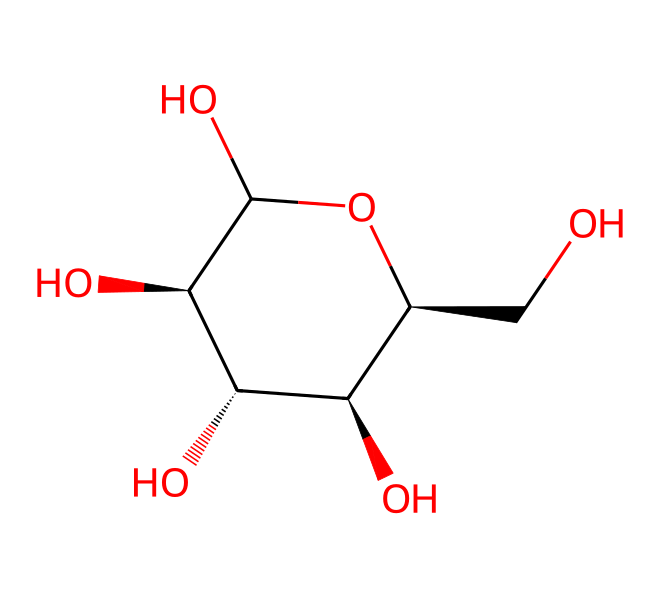What is the molecular formula of this compound? To determine the molecular formula, we need to count the number of each type of atom in the SMILES representation. The structure represents a carbohydrate, specifically cellulose, which contains carbon (C), hydrogen (H), and oxygen (O). By analyzing the SMILES, we identify 6 carbon atoms, 10 hydrogen atoms, and 5 oxygen atoms, resulting in the molecular formula C6H10O5.
Answer: C6H10O5 How many hydroxyl (OH) groups are present in this structure? The presence of hydroxyl groups can be determined by identifying -OH functional groups in the structure. Each carbon in cellulose typically has a hydroxyl group attached, and by inspecting the structure from the SMILES representation, we find 4 distinct hydroxyl groups attached to the carbon backbone.
Answer: 4 What type of bonds are primarily present in this compound? Aliphatic compounds, like cellulose, predominantly contain single (sigma) bonds. By analyzing the SMILES, we can observe that the connections between the carbon atoms and with other functional groups are mainly single bonds. Additional checks for double or triple bonds reveal none present, confirming the presence of single bonds.
Answer: single bonds What is the significance of this compound in biofuels? The significance of cellulose in biofuels lies in its potential as a renewable resource. It is a polysaccharide that can be broken down into glucose through enzymatic hydrolysis, which can then be fermented to produce ethanol. This sustainable process directly connects cellulose to biofuel production, emphasizing its role in reducing dependence on fossil fuels.
Answer: renewable resource Is this compound a simple sugar or a polysaccharide? By examining the structure, we can determine the classification of the carbohydrate. The chemical in question is a complex molecule formed by multiple monosaccharide units, making it a polysaccharide, as opposed to a simple sugar like glucose which consists of a single unit.
Answer: polysaccharide How many rings are present in the structure? The structure depicted in the SMILES represents a cyclic structure which is typical for polysaccharides. In cellulose, we don't see distinct rings as in cyclic compounds but rather a chain-like structure that refers to a repeating unit rather than a closed ring. Upon further analysis, this unit format contributes to the overall non-ringed yet cycle-like appearance.
Answer: 0 